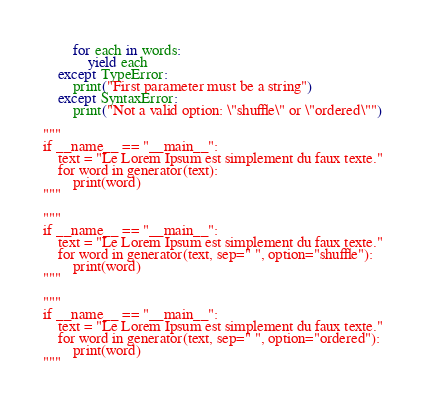Convert code to text. <code><loc_0><loc_0><loc_500><loc_500><_Python_>		for each in words:
			yield each
	except TypeError:
		print("First parameter must be a string")
	except SyntaxError:
		print("Not a valid option: \"shuffle\" or \"ordered\"")
	
"""
if __name__ == "__main__":
	text = "Le Lorem Ipsum est simplement du faux texte."
	for word in generator(text):
		print(word)
"""

"""
if __name__ == "__main__":
	text = "Le Lorem Ipsum est simplement du faux texte."
	for word in generator(text, sep=" ", option="shuffle"):
		print(word)
"""

"""
if __name__ == "__main__":
	text = "Le Lorem Ipsum est simplement du faux texte."
	for word in generator(text, sep=" ", option="ordered"):
		print(word)
"""</code> 